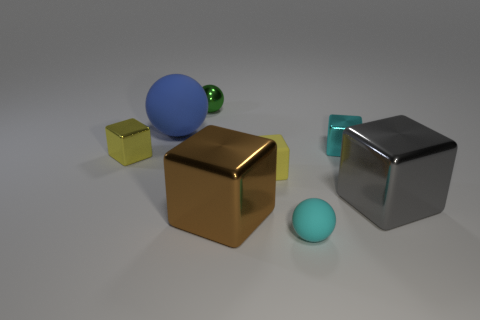What number of green things are either big metal blocks or tiny rubber blocks?
Provide a short and direct response. 0. Are there more large cubes on the left side of the cyan rubber thing than small blue rubber objects?
Provide a succinct answer. Yes. Is the blue object the same size as the yellow metallic cube?
Offer a terse response. No. There is another large cube that is made of the same material as the gray cube; what color is it?
Give a very brief answer. Brown. The small metallic object that is the same color as the tiny matte ball is what shape?
Offer a terse response. Cube. Are there the same number of gray things behind the large rubber ball and balls that are in front of the yellow shiny thing?
Your response must be concise. No. There is a small cyan thing behind the small yellow cube that is on the left side of the big sphere; what shape is it?
Make the answer very short. Cube. What material is the gray thing that is the same shape as the brown thing?
Your response must be concise. Metal. What color is the matte ball that is the same size as the brown thing?
Provide a short and direct response. Blue. Are there the same number of cubes that are in front of the gray block and yellow matte things?
Provide a succinct answer. Yes. 